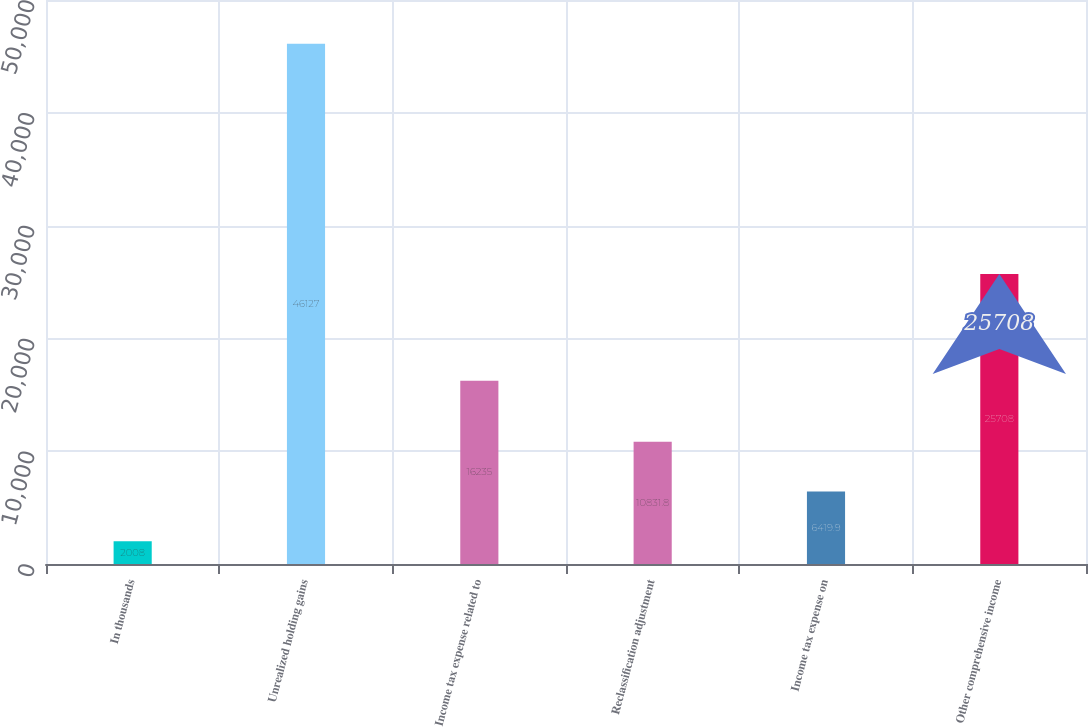Convert chart to OTSL. <chart><loc_0><loc_0><loc_500><loc_500><bar_chart><fcel>In thousands<fcel>Unrealized holding gains<fcel>Income tax expense related to<fcel>Reclassification adjustment<fcel>Income tax expense on<fcel>Other comprehensive income<nl><fcel>2008<fcel>46127<fcel>16235<fcel>10831.8<fcel>6419.9<fcel>25708<nl></chart> 